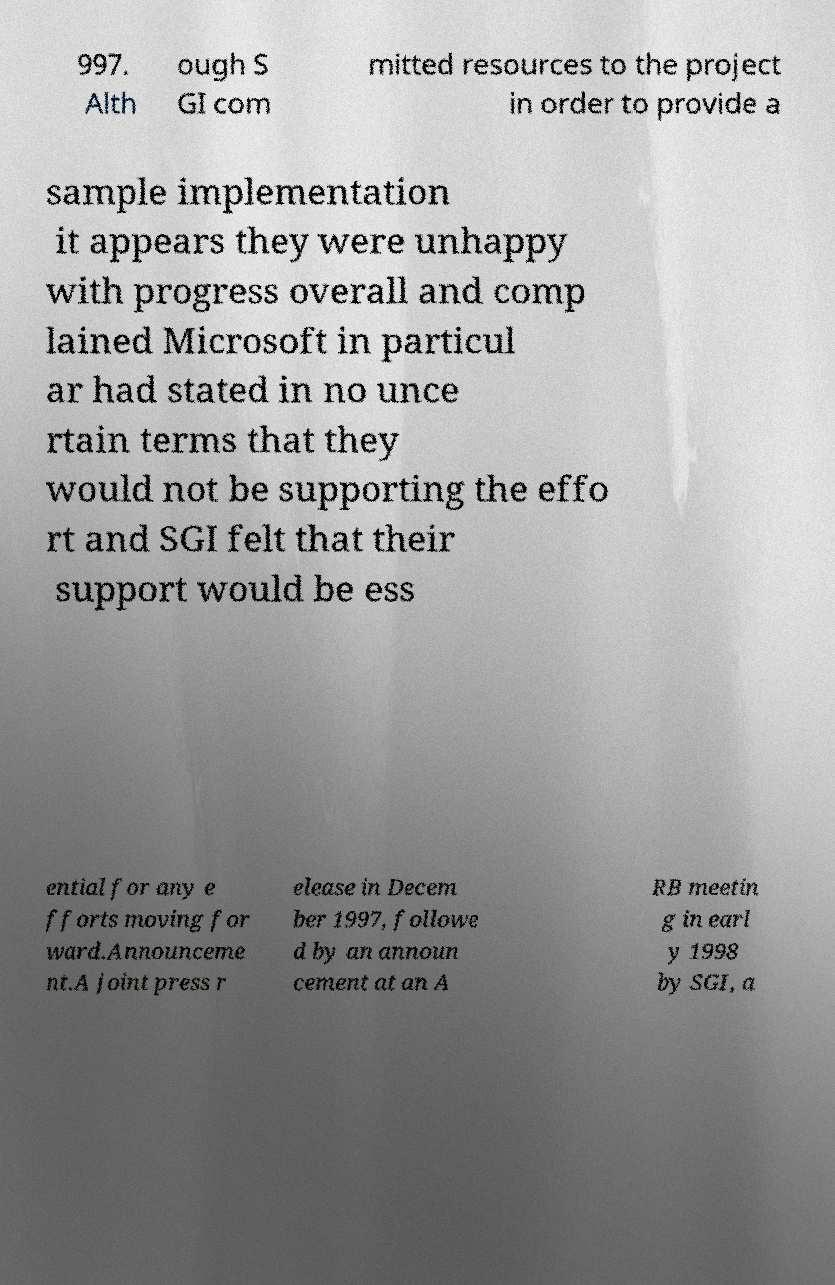Please read and relay the text visible in this image. What does it say? 997. Alth ough S GI com mitted resources to the project in order to provide a sample implementation it appears they were unhappy with progress overall and comp lained Microsoft in particul ar had stated in no unce rtain terms that they would not be supporting the effo rt and SGI felt that their support would be ess ential for any e fforts moving for ward.Announceme nt.A joint press r elease in Decem ber 1997, followe d by an announ cement at an A RB meetin g in earl y 1998 by SGI, a 